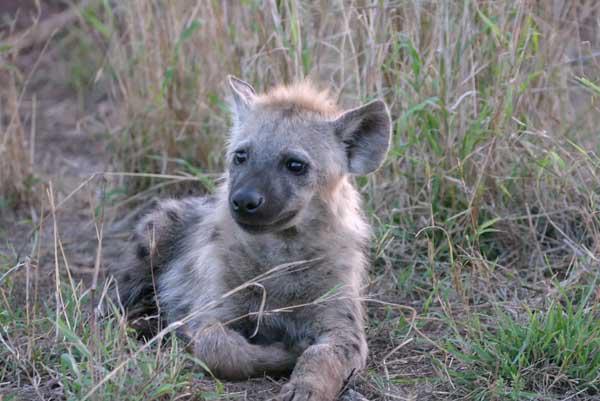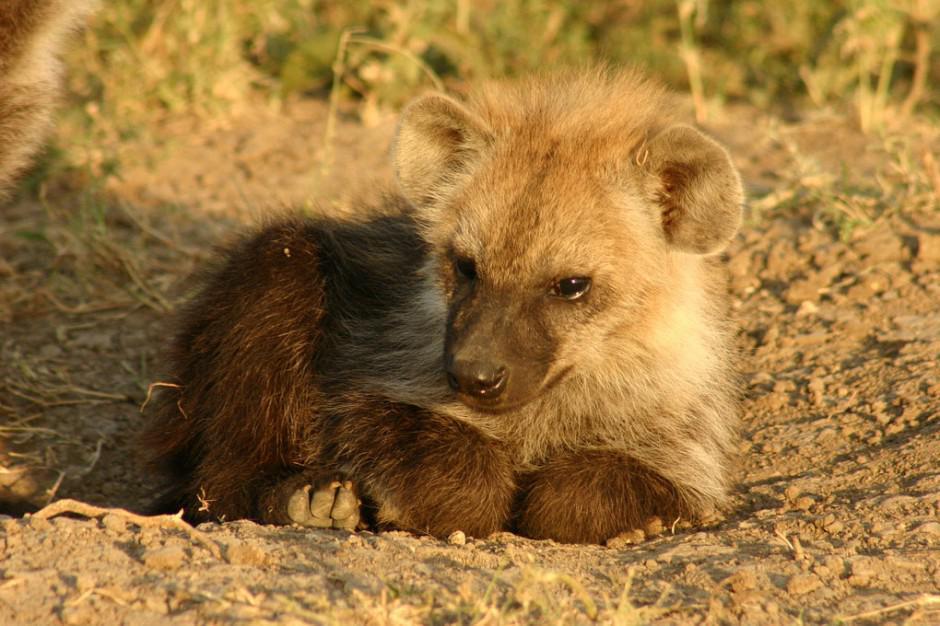The first image is the image on the left, the second image is the image on the right. Examine the images to the left and right. Is the description "Each image features one hyena with distinctive spotted fur, and the hyena on the left has its head turned around, while the hyena on the right reclines with its front paws extended." accurate? Answer yes or no. No. The first image is the image on the left, the second image is the image on the right. Assess this claim about the two images: "There is a single adult hyena in each image, but they are looking in opposite directions.". Correct or not? Answer yes or no. No. 